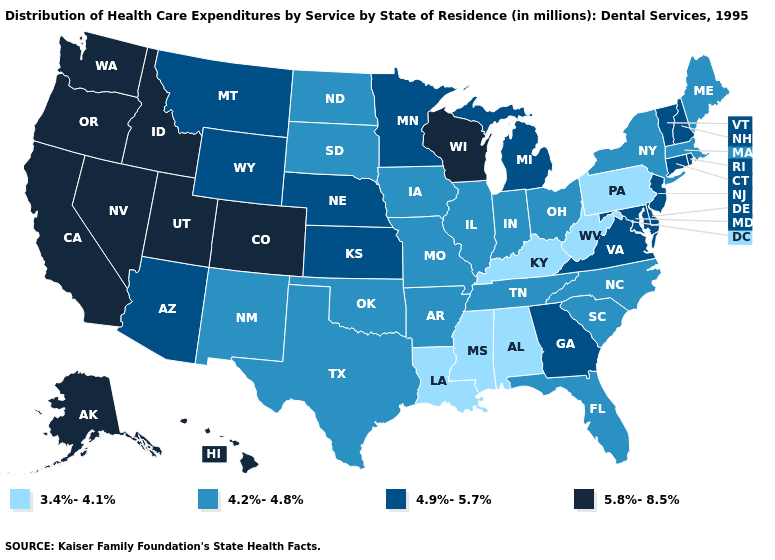What is the value of Iowa?
Quick response, please. 4.2%-4.8%. What is the highest value in states that border Vermont?
Be succinct. 4.9%-5.7%. Is the legend a continuous bar?
Give a very brief answer. No. Name the states that have a value in the range 3.4%-4.1%?
Write a very short answer. Alabama, Kentucky, Louisiana, Mississippi, Pennsylvania, West Virginia. Among the states that border Ohio , does Kentucky have the highest value?
Give a very brief answer. No. Does the first symbol in the legend represent the smallest category?
Concise answer only. Yes. What is the value of New Mexico?
Give a very brief answer. 4.2%-4.8%. Name the states that have a value in the range 3.4%-4.1%?
Short answer required. Alabama, Kentucky, Louisiana, Mississippi, Pennsylvania, West Virginia. Does Georgia have a lower value than Missouri?
Give a very brief answer. No. Name the states that have a value in the range 4.2%-4.8%?
Keep it brief. Arkansas, Florida, Illinois, Indiana, Iowa, Maine, Massachusetts, Missouri, New Mexico, New York, North Carolina, North Dakota, Ohio, Oklahoma, South Carolina, South Dakota, Tennessee, Texas. Name the states that have a value in the range 4.9%-5.7%?
Concise answer only. Arizona, Connecticut, Delaware, Georgia, Kansas, Maryland, Michigan, Minnesota, Montana, Nebraska, New Hampshire, New Jersey, Rhode Island, Vermont, Virginia, Wyoming. What is the value of North Carolina?
Answer briefly. 4.2%-4.8%. What is the value of Alaska?
Concise answer only. 5.8%-8.5%. Name the states that have a value in the range 4.9%-5.7%?
Keep it brief. Arizona, Connecticut, Delaware, Georgia, Kansas, Maryland, Michigan, Minnesota, Montana, Nebraska, New Hampshire, New Jersey, Rhode Island, Vermont, Virginia, Wyoming. What is the value of Utah?
Concise answer only. 5.8%-8.5%. 